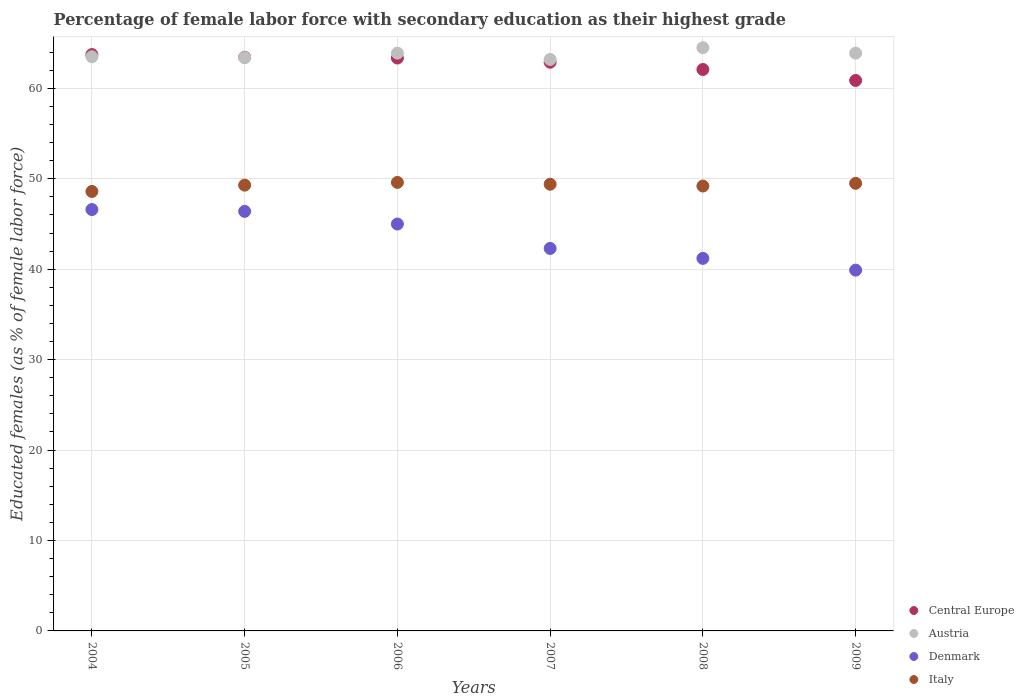What is the percentage of female labor force with secondary education in Austria in 2009?
Offer a very short reply. 63.9. Across all years, what is the maximum percentage of female labor force with secondary education in Central Europe?
Make the answer very short. 63.74. Across all years, what is the minimum percentage of female labor force with secondary education in Italy?
Give a very brief answer. 48.6. What is the total percentage of female labor force with secondary education in Italy in the graph?
Offer a very short reply. 295.6. What is the difference between the percentage of female labor force with secondary education in Italy in 2008 and that in 2009?
Your answer should be compact. -0.3. What is the difference between the percentage of female labor force with secondary education in Austria in 2004 and the percentage of female labor force with secondary education in Denmark in 2009?
Offer a very short reply. 23.6. What is the average percentage of female labor force with secondary education in Denmark per year?
Your response must be concise. 43.57. In the year 2004, what is the difference between the percentage of female labor force with secondary education in Austria and percentage of female labor force with secondary education in Central Europe?
Your answer should be compact. -0.24. What is the ratio of the percentage of female labor force with secondary education in Denmark in 2007 to that in 2009?
Ensure brevity in your answer.  1.06. Is the percentage of female labor force with secondary education in Italy in 2005 less than that in 2008?
Provide a succinct answer. No. What is the difference between the highest and the second highest percentage of female labor force with secondary education in Denmark?
Offer a very short reply. 0.2. What is the difference between the highest and the lowest percentage of female labor force with secondary education in Italy?
Make the answer very short. 1. Is the percentage of female labor force with secondary education in Italy strictly less than the percentage of female labor force with secondary education in Austria over the years?
Your answer should be compact. Yes. How many dotlines are there?
Ensure brevity in your answer.  4. What is the difference between two consecutive major ticks on the Y-axis?
Offer a terse response. 10. Does the graph contain any zero values?
Provide a short and direct response. No. Where does the legend appear in the graph?
Make the answer very short. Bottom right. How many legend labels are there?
Your answer should be compact. 4. What is the title of the graph?
Offer a very short reply. Percentage of female labor force with secondary education as their highest grade. What is the label or title of the Y-axis?
Ensure brevity in your answer.  Educated females (as % of female labor force). What is the Educated females (as % of female labor force) in Central Europe in 2004?
Ensure brevity in your answer.  63.74. What is the Educated females (as % of female labor force) in Austria in 2004?
Make the answer very short. 63.5. What is the Educated females (as % of female labor force) of Denmark in 2004?
Give a very brief answer. 46.6. What is the Educated females (as % of female labor force) of Italy in 2004?
Provide a succinct answer. 48.6. What is the Educated females (as % of female labor force) of Central Europe in 2005?
Your answer should be very brief. 63.44. What is the Educated females (as % of female labor force) in Austria in 2005?
Your answer should be very brief. 63.4. What is the Educated females (as % of female labor force) of Denmark in 2005?
Provide a short and direct response. 46.4. What is the Educated females (as % of female labor force) in Italy in 2005?
Offer a very short reply. 49.3. What is the Educated females (as % of female labor force) of Central Europe in 2006?
Provide a succinct answer. 63.36. What is the Educated females (as % of female labor force) of Austria in 2006?
Ensure brevity in your answer.  63.9. What is the Educated females (as % of female labor force) in Italy in 2006?
Offer a terse response. 49.6. What is the Educated females (as % of female labor force) in Central Europe in 2007?
Ensure brevity in your answer.  62.89. What is the Educated females (as % of female labor force) of Austria in 2007?
Offer a very short reply. 63.2. What is the Educated females (as % of female labor force) in Denmark in 2007?
Your answer should be compact. 42.3. What is the Educated females (as % of female labor force) of Italy in 2007?
Offer a terse response. 49.4. What is the Educated females (as % of female labor force) of Central Europe in 2008?
Ensure brevity in your answer.  62.09. What is the Educated females (as % of female labor force) in Austria in 2008?
Provide a succinct answer. 64.5. What is the Educated females (as % of female labor force) in Denmark in 2008?
Offer a very short reply. 41.2. What is the Educated females (as % of female labor force) in Italy in 2008?
Your answer should be very brief. 49.2. What is the Educated females (as % of female labor force) of Central Europe in 2009?
Offer a very short reply. 60.88. What is the Educated females (as % of female labor force) in Austria in 2009?
Your answer should be compact. 63.9. What is the Educated females (as % of female labor force) in Denmark in 2009?
Offer a very short reply. 39.9. What is the Educated females (as % of female labor force) in Italy in 2009?
Offer a terse response. 49.5. Across all years, what is the maximum Educated females (as % of female labor force) of Central Europe?
Your answer should be compact. 63.74. Across all years, what is the maximum Educated females (as % of female labor force) of Austria?
Provide a succinct answer. 64.5. Across all years, what is the maximum Educated females (as % of female labor force) in Denmark?
Offer a terse response. 46.6. Across all years, what is the maximum Educated females (as % of female labor force) in Italy?
Provide a succinct answer. 49.6. Across all years, what is the minimum Educated females (as % of female labor force) in Central Europe?
Your response must be concise. 60.88. Across all years, what is the minimum Educated females (as % of female labor force) in Austria?
Offer a terse response. 63.2. Across all years, what is the minimum Educated females (as % of female labor force) of Denmark?
Your answer should be compact. 39.9. Across all years, what is the minimum Educated females (as % of female labor force) of Italy?
Give a very brief answer. 48.6. What is the total Educated females (as % of female labor force) in Central Europe in the graph?
Your answer should be very brief. 376.39. What is the total Educated females (as % of female labor force) in Austria in the graph?
Make the answer very short. 382.4. What is the total Educated females (as % of female labor force) in Denmark in the graph?
Make the answer very short. 261.4. What is the total Educated females (as % of female labor force) in Italy in the graph?
Your response must be concise. 295.6. What is the difference between the Educated females (as % of female labor force) of Central Europe in 2004 and that in 2005?
Give a very brief answer. 0.3. What is the difference between the Educated females (as % of female labor force) of Austria in 2004 and that in 2005?
Provide a short and direct response. 0.1. What is the difference between the Educated females (as % of female labor force) of Central Europe in 2004 and that in 2006?
Your answer should be compact. 0.38. What is the difference between the Educated females (as % of female labor force) in Central Europe in 2004 and that in 2007?
Provide a succinct answer. 0.84. What is the difference between the Educated females (as % of female labor force) of Denmark in 2004 and that in 2007?
Keep it short and to the point. 4.3. What is the difference between the Educated females (as % of female labor force) of Central Europe in 2004 and that in 2008?
Offer a very short reply. 1.65. What is the difference between the Educated females (as % of female labor force) of Italy in 2004 and that in 2008?
Offer a terse response. -0.6. What is the difference between the Educated females (as % of female labor force) in Central Europe in 2004 and that in 2009?
Your answer should be very brief. 2.86. What is the difference between the Educated females (as % of female labor force) in Italy in 2004 and that in 2009?
Offer a very short reply. -0.9. What is the difference between the Educated females (as % of female labor force) of Central Europe in 2005 and that in 2006?
Your response must be concise. 0.08. What is the difference between the Educated females (as % of female labor force) of Denmark in 2005 and that in 2006?
Make the answer very short. 1.4. What is the difference between the Educated females (as % of female labor force) in Central Europe in 2005 and that in 2007?
Ensure brevity in your answer.  0.54. What is the difference between the Educated females (as % of female labor force) of Austria in 2005 and that in 2007?
Your response must be concise. 0.2. What is the difference between the Educated females (as % of female labor force) of Italy in 2005 and that in 2007?
Ensure brevity in your answer.  -0.1. What is the difference between the Educated females (as % of female labor force) in Central Europe in 2005 and that in 2008?
Provide a succinct answer. 1.34. What is the difference between the Educated females (as % of female labor force) in Austria in 2005 and that in 2008?
Offer a very short reply. -1.1. What is the difference between the Educated females (as % of female labor force) of Denmark in 2005 and that in 2008?
Keep it short and to the point. 5.2. What is the difference between the Educated females (as % of female labor force) of Italy in 2005 and that in 2008?
Provide a succinct answer. 0.1. What is the difference between the Educated females (as % of female labor force) of Central Europe in 2005 and that in 2009?
Provide a short and direct response. 2.56. What is the difference between the Educated females (as % of female labor force) in Austria in 2005 and that in 2009?
Your answer should be very brief. -0.5. What is the difference between the Educated females (as % of female labor force) in Italy in 2005 and that in 2009?
Offer a very short reply. -0.2. What is the difference between the Educated females (as % of female labor force) of Central Europe in 2006 and that in 2007?
Ensure brevity in your answer.  0.46. What is the difference between the Educated females (as % of female labor force) in Austria in 2006 and that in 2007?
Offer a terse response. 0.7. What is the difference between the Educated females (as % of female labor force) of Central Europe in 2006 and that in 2008?
Offer a very short reply. 1.27. What is the difference between the Educated females (as % of female labor force) of Austria in 2006 and that in 2008?
Keep it short and to the point. -0.6. What is the difference between the Educated females (as % of female labor force) of Italy in 2006 and that in 2008?
Ensure brevity in your answer.  0.4. What is the difference between the Educated females (as % of female labor force) in Central Europe in 2006 and that in 2009?
Offer a terse response. 2.48. What is the difference between the Educated females (as % of female labor force) of Denmark in 2006 and that in 2009?
Make the answer very short. 5.1. What is the difference between the Educated females (as % of female labor force) in Central Europe in 2007 and that in 2008?
Keep it short and to the point. 0.8. What is the difference between the Educated females (as % of female labor force) of Central Europe in 2007 and that in 2009?
Your answer should be compact. 2.01. What is the difference between the Educated females (as % of female labor force) of Austria in 2007 and that in 2009?
Your answer should be compact. -0.7. What is the difference between the Educated females (as % of female labor force) of Denmark in 2007 and that in 2009?
Give a very brief answer. 2.4. What is the difference between the Educated females (as % of female labor force) of Central Europe in 2008 and that in 2009?
Your answer should be compact. 1.21. What is the difference between the Educated females (as % of female labor force) of Austria in 2008 and that in 2009?
Ensure brevity in your answer.  0.6. What is the difference between the Educated females (as % of female labor force) in Italy in 2008 and that in 2009?
Keep it short and to the point. -0.3. What is the difference between the Educated females (as % of female labor force) in Central Europe in 2004 and the Educated females (as % of female labor force) in Austria in 2005?
Provide a short and direct response. 0.34. What is the difference between the Educated females (as % of female labor force) of Central Europe in 2004 and the Educated females (as % of female labor force) of Denmark in 2005?
Make the answer very short. 17.34. What is the difference between the Educated females (as % of female labor force) in Central Europe in 2004 and the Educated females (as % of female labor force) in Italy in 2005?
Keep it short and to the point. 14.44. What is the difference between the Educated females (as % of female labor force) in Austria in 2004 and the Educated females (as % of female labor force) in Denmark in 2005?
Your answer should be very brief. 17.1. What is the difference between the Educated females (as % of female labor force) of Austria in 2004 and the Educated females (as % of female labor force) of Italy in 2005?
Your answer should be compact. 14.2. What is the difference between the Educated females (as % of female labor force) in Denmark in 2004 and the Educated females (as % of female labor force) in Italy in 2005?
Provide a short and direct response. -2.7. What is the difference between the Educated females (as % of female labor force) in Central Europe in 2004 and the Educated females (as % of female labor force) in Austria in 2006?
Give a very brief answer. -0.16. What is the difference between the Educated females (as % of female labor force) of Central Europe in 2004 and the Educated females (as % of female labor force) of Denmark in 2006?
Provide a succinct answer. 18.74. What is the difference between the Educated females (as % of female labor force) in Central Europe in 2004 and the Educated females (as % of female labor force) in Italy in 2006?
Your response must be concise. 14.14. What is the difference between the Educated females (as % of female labor force) of Austria in 2004 and the Educated females (as % of female labor force) of Italy in 2006?
Ensure brevity in your answer.  13.9. What is the difference between the Educated females (as % of female labor force) in Central Europe in 2004 and the Educated females (as % of female labor force) in Austria in 2007?
Your answer should be very brief. 0.54. What is the difference between the Educated females (as % of female labor force) in Central Europe in 2004 and the Educated females (as % of female labor force) in Denmark in 2007?
Provide a succinct answer. 21.44. What is the difference between the Educated females (as % of female labor force) of Central Europe in 2004 and the Educated females (as % of female labor force) of Italy in 2007?
Provide a succinct answer. 14.34. What is the difference between the Educated females (as % of female labor force) of Austria in 2004 and the Educated females (as % of female labor force) of Denmark in 2007?
Provide a succinct answer. 21.2. What is the difference between the Educated females (as % of female labor force) in Austria in 2004 and the Educated females (as % of female labor force) in Italy in 2007?
Ensure brevity in your answer.  14.1. What is the difference between the Educated females (as % of female labor force) in Denmark in 2004 and the Educated females (as % of female labor force) in Italy in 2007?
Keep it short and to the point. -2.8. What is the difference between the Educated females (as % of female labor force) of Central Europe in 2004 and the Educated females (as % of female labor force) of Austria in 2008?
Make the answer very short. -0.76. What is the difference between the Educated females (as % of female labor force) in Central Europe in 2004 and the Educated females (as % of female labor force) in Denmark in 2008?
Make the answer very short. 22.54. What is the difference between the Educated females (as % of female labor force) of Central Europe in 2004 and the Educated females (as % of female labor force) of Italy in 2008?
Your response must be concise. 14.54. What is the difference between the Educated females (as % of female labor force) in Austria in 2004 and the Educated females (as % of female labor force) in Denmark in 2008?
Give a very brief answer. 22.3. What is the difference between the Educated females (as % of female labor force) of Austria in 2004 and the Educated females (as % of female labor force) of Italy in 2008?
Provide a succinct answer. 14.3. What is the difference between the Educated females (as % of female labor force) in Denmark in 2004 and the Educated females (as % of female labor force) in Italy in 2008?
Your answer should be very brief. -2.6. What is the difference between the Educated females (as % of female labor force) of Central Europe in 2004 and the Educated females (as % of female labor force) of Austria in 2009?
Your answer should be very brief. -0.16. What is the difference between the Educated females (as % of female labor force) in Central Europe in 2004 and the Educated females (as % of female labor force) in Denmark in 2009?
Give a very brief answer. 23.84. What is the difference between the Educated females (as % of female labor force) of Central Europe in 2004 and the Educated females (as % of female labor force) of Italy in 2009?
Keep it short and to the point. 14.24. What is the difference between the Educated females (as % of female labor force) in Austria in 2004 and the Educated females (as % of female labor force) in Denmark in 2009?
Your response must be concise. 23.6. What is the difference between the Educated females (as % of female labor force) in Austria in 2004 and the Educated females (as % of female labor force) in Italy in 2009?
Make the answer very short. 14. What is the difference between the Educated females (as % of female labor force) of Denmark in 2004 and the Educated females (as % of female labor force) of Italy in 2009?
Provide a short and direct response. -2.9. What is the difference between the Educated females (as % of female labor force) of Central Europe in 2005 and the Educated females (as % of female labor force) of Austria in 2006?
Your answer should be very brief. -0.46. What is the difference between the Educated females (as % of female labor force) in Central Europe in 2005 and the Educated females (as % of female labor force) in Denmark in 2006?
Keep it short and to the point. 18.44. What is the difference between the Educated females (as % of female labor force) of Central Europe in 2005 and the Educated females (as % of female labor force) of Italy in 2006?
Your answer should be very brief. 13.84. What is the difference between the Educated females (as % of female labor force) of Austria in 2005 and the Educated females (as % of female labor force) of Italy in 2006?
Provide a short and direct response. 13.8. What is the difference between the Educated females (as % of female labor force) of Denmark in 2005 and the Educated females (as % of female labor force) of Italy in 2006?
Your response must be concise. -3.2. What is the difference between the Educated females (as % of female labor force) in Central Europe in 2005 and the Educated females (as % of female labor force) in Austria in 2007?
Make the answer very short. 0.24. What is the difference between the Educated females (as % of female labor force) in Central Europe in 2005 and the Educated females (as % of female labor force) in Denmark in 2007?
Give a very brief answer. 21.14. What is the difference between the Educated females (as % of female labor force) in Central Europe in 2005 and the Educated females (as % of female labor force) in Italy in 2007?
Keep it short and to the point. 14.04. What is the difference between the Educated females (as % of female labor force) of Austria in 2005 and the Educated females (as % of female labor force) of Denmark in 2007?
Give a very brief answer. 21.1. What is the difference between the Educated females (as % of female labor force) in Austria in 2005 and the Educated females (as % of female labor force) in Italy in 2007?
Your answer should be very brief. 14. What is the difference between the Educated females (as % of female labor force) of Denmark in 2005 and the Educated females (as % of female labor force) of Italy in 2007?
Your answer should be very brief. -3. What is the difference between the Educated females (as % of female labor force) of Central Europe in 2005 and the Educated females (as % of female labor force) of Austria in 2008?
Keep it short and to the point. -1.06. What is the difference between the Educated females (as % of female labor force) of Central Europe in 2005 and the Educated females (as % of female labor force) of Denmark in 2008?
Provide a short and direct response. 22.24. What is the difference between the Educated females (as % of female labor force) in Central Europe in 2005 and the Educated females (as % of female labor force) in Italy in 2008?
Your answer should be very brief. 14.24. What is the difference between the Educated females (as % of female labor force) in Austria in 2005 and the Educated females (as % of female labor force) in Denmark in 2008?
Make the answer very short. 22.2. What is the difference between the Educated females (as % of female labor force) in Denmark in 2005 and the Educated females (as % of female labor force) in Italy in 2008?
Your response must be concise. -2.8. What is the difference between the Educated females (as % of female labor force) of Central Europe in 2005 and the Educated females (as % of female labor force) of Austria in 2009?
Give a very brief answer. -0.46. What is the difference between the Educated females (as % of female labor force) of Central Europe in 2005 and the Educated females (as % of female labor force) of Denmark in 2009?
Give a very brief answer. 23.54. What is the difference between the Educated females (as % of female labor force) of Central Europe in 2005 and the Educated females (as % of female labor force) of Italy in 2009?
Keep it short and to the point. 13.94. What is the difference between the Educated females (as % of female labor force) in Austria in 2005 and the Educated females (as % of female labor force) in Denmark in 2009?
Keep it short and to the point. 23.5. What is the difference between the Educated females (as % of female labor force) of Austria in 2005 and the Educated females (as % of female labor force) of Italy in 2009?
Provide a succinct answer. 13.9. What is the difference between the Educated females (as % of female labor force) in Central Europe in 2006 and the Educated females (as % of female labor force) in Austria in 2007?
Your response must be concise. 0.16. What is the difference between the Educated females (as % of female labor force) in Central Europe in 2006 and the Educated females (as % of female labor force) in Denmark in 2007?
Provide a succinct answer. 21.06. What is the difference between the Educated females (as % of female labor force) of Central Europe in 2006 and the Educated females (as % of female labor force) of Italy in 2007?
Provide a short and direct response. 13.96. What is the difference between the Educated females (as % of female labor force) of Austria in 2006 and the Educated females (as % of female labor force) of Denmark in 2007?
Provide a short and direct response. 21.6. What is the difference between the Educated females (as % of female labor force) of Denmark in 2006 and the Educated females (as % of female labor force) of Italy in 2007?
Your answer should be compact. -4.4. What is the difference between the Educated females (as % of female labor force) of Central Europe in 2006 and the Educated females (as % of female labor force) of Austria in 2008?
Make the answer very short. -1.14. What is the difference between the Educated females (as % of female labor force) of Central Europe in 2006 and the Educated females (as % of female labor force) of Denmark in 2008?
Keep it short and to the point. 22.16. What is the difference between the Educated females (as % of female labor force) of Central Europe in 2006 and the Educated females (as % of female labor force) of Italy in 2008?
Your answer should be compact. 14.16. What is the difference between the Educated females (as % of female labor force) in Austria in 2006 and the Educated females (as % of female labor force) in Denmark in 2008?
Your answer should be compact. 22.7. What is the difference between the Educated females (as % of female labor force) of Austria in 2006 and the Educated females (as % of female labor force) of Italy in 2008?
Your answer should be compact. 14.7. What is the difference between the Educated females (as % of female labor force) of Denmark in 2006 and the Educated females (as % of female labor force) of Italy in 2008?
Provide a succinct answer. -4.2. What is the difference between the Educated females (as % of female labor force) of Central Europe in 2006 and the Educated females (as % of female labor force) of Austria in 2009?
Give a very brief answer. -0.54. What is the difference between the Educated females (as % of female labor force) of Central Europe in 2006 and the Educated females (as % of female labor force) of Denmark in 2009?
Your response must be concise. 23.46. What is the difference between the Educated females (as % of female labor force) of Central Europe in 2006 and the Educated females (as % of female labor force) of Italy in 2009?
Your answer should be compact. 13.86. What is the difference between the Educated females (as % of female labor force) of Austria in 2006 and the Educated females (as % of female labor force) of Denmark in 2009?
Your answer should be compact. 24. What is the difference between the Educated females (as % of female labor force) of Austria in 2006 and the Educated females (as % of female labor force) of Italy in 2009?
Offer a terse response. 14.4. What is the difference between the Educated females (as % of female labor force) of Denmark in 2006 and the Educated females (as % of female labor force) of Italy in 2009?
Ensure brevity in your answer.  -4.5. What is the difference between the Educated females (as % of female labor force) of Central Europe in 2007 and the Educated females (as % of female labor force) of Austria in 2008?
Offer a terse response. -1.61. What is the difference between the Educated females (as % of female labor force) in Central Europe in 2007 and the Educated females (as % of female labor force) in Denmark in 2008?
Offer a very short reply. 21.69. What is the difference between the Educated females (as % of female labor force) in Central Europe in 2007 and the Educated females (as % of female labor force) in Italy in 2008?
Your answer should be compact. 13.69. What is the difference between the Educated females (as % of female labor force) in Austria in 2007 and the Educated females (as % of female labor force) in Denmark in 2008?
Offer a terse response. 22. What is the difference between the Educated females (as % of female labor force) of Central Europe in 2007 and the Educated females (as % of female labor force) of Austria in 2009?
Keep it short and to the point. -1.01. What is the difference between the Educated females (as % of female labor force) in Central Europe in 2007 and the Educated females (as % of female labor force) in Denmark in 2009?
Your answer should be compact. 22.99. What is the difference between the Educated females (as % of female labor force) of Central Europe in 2007 and the Educated females (as % of female labor force) of Italy in 2009?
Keep it short and to the point. 13.39. What is the difference between the Educated females (as % of female labor force) of Austria in 2007 and the Educated females (as % of female labor force) of Denmark in 2009?
Offer a very short reply. 23.3. What is the difference between the Educated females (as % of female labor force) in Austria in 2007 and the Educated females (as % of female labor force) in Italy in 2009?
Offer a terse response. 13.7. What is the difference between the Educated females (as % of female labor force) in Central Europe in 2008 and the Educated females (as % of female labor force) in Austria in 2009?
Your answer should be very brief. -1.81. What is the difference between the Educated females (as % of female labor force) in Central Europe in 2008 and the Educated females (as % of female labor force) in Denmark in 2009?
Ensure brevity in your answer.  22.19. What is the difference between the Educated females (as % of female labor force) of Central Europe in 2008 and the Educated females (as % of female labor force) of Italy in 2009?
Your answer should be very brief. 12.59. What is the difference between the Educated females (as % of female labor force) in Austria in 2008 and the Educated females (as % of female labor force) in Denmark in 2009?
Your response must be concise. 24.6. What is the difference between the Educated females (as % of female labor force) of Austria in 2008 and the Educated females (as % of female labor force) of Italy in 2009?
Your answer should be very brief. 15. What is the average Educated females (as % of female labor force) in Central Europe per year?
Give a very brief answer. 62.73. What is the average Educated females (as % of female labor force) of Austria per year?
Provide a succinct answer. 63.73. What is the average Educated females (as % of female labor force) of Denmark per year?
Your answer should be very brief. 43.57. What is the average Educated females (as % of female labor force) in Italy per year?
Provide a short and direct response. 49.27. In the year 2004, what is the difference between the Educated females (as % of female labor force) in Central Europe and Educated females (as % of female labor force) in Austria?
Your response must be concise. 0.24. In the year 2004, what is the difference between the Educated females (as % of female labor force) of Central Europe and Educated females (as % of female labor force) of Denmark?
Offer a terse response. 17.14. In the year 2004, what is the difference between the Educated females (as % of female labor force) of Central Europe and Educated females (as % of female labor force) of Italy?
Provide a short and direct response. 15.14. In the year 2004, what is the difference between the Educated females (as % of female labor force) in Austria and Educated females (as % of female labor force) in Denmark?
Your response must be concise. 16.9. In the year 2005, what is the difference between the Educated females (as % of female labor force) in Central Europe and Educated females (as % of female labor force) in Austria?
Your response must be concise. 0.04. In the year 2005, what is the difference between the Educated females (as % of female labor force) in Central Europe and Educated females (as % of female labor force) in Denmark?
Make the answer very short. 17.04. In the year 2005, what is the difference between the Educated females (as % of female labor force) in Central Europe and Educated females (as % of female labor force) in Italy?
Your response must be concise. 14.14. In the year 2005, what is the difference between the Educated females (as % of female labor force) of Austria and Educated females (as % of female labor force) of Denmark?
Offer a terse response. 17. In the year 2006, what is the difference between the Educated females (as % of female labor force) of Central Europe and Educated females (as % of female labor force) of Austria?
Provide a short and direct response. -0.54. In the year 2006, what is the difference between the Educated females (as % of female labor force) in Central Europe and Educated females (as % of female labor force) in Denmark?
Keep it short and to the point. 18.36. In the year 2006, what is the difference between the Educated females (as % of female labor force) in Central Europe and Educated females (as % of female labor force) in Italy?
Your answer should be compact. 13.76. In the year 2006, what is the difference between the Educated females (as % of female labor force) of Austria and Educated females (as % of female labor force) of Italy?
Ensure brevity in your answer.  14.3. In the year 2007, what is the difference between the Educated females (as % of female labor force) in Central Europe and Educated females (as % of female labor force) in Austria?
Ensure brevity in your answer.  -0.31. In the year 2007, what is the difference between the Educated females (as % of female labor force) of Central Europe and Educated females (as % of female labor force) of Denmark?
Provide a succinct answer. 20.59. In the year 2007, what is the difference between the Educated females (as % of female labor force) in Central Europe and Educated females (as % of female labor force) in Italy?
Your answer should be compact. 13.49. In the year 2007, what is the difference between the Educated females (as % of female labor force) of Austria and Educated females (as % of female labor force) of Denmark?
Ensure brevity in your answer.  20.9. In the year 2007, what is the difference between the Educated females (as % of female labor force) of Denmark and Educated females (as % of female labor force) of Italy?
Provide a succinct answer. -7.1. In the year 2008, what is the difference between the Educated females (as % of female labor force) of Central Europe and Educated females (as % of female labor force) of Austria?
Ensure brevity in your answer.  -2.41. In the year 2008, what is the difference between the Educated females (as % of female labor force) of Central Europe and Educated females (as % of female labor force) of Denmark?
Offer a very short reply. 20.89. In the year 2008, what is the difference between the Educated females (as % of female labor force) of Central Europe and Educated females (as % of female labor force) of Italy?
Provide a short and direct response. 12.89. In the year 2008, what is the difference between the Educated females (as % of female labor force) of Austria and Educated females (as % of female labor force) of Denmark?
Offer a very short reply. 23.3. In the year 2008, what is the difference between the Educated females (as % of female labor force) in Austria and Educated females (as % of female labor force) in Italy?
Your answer should be very brief. 15.3. In the year 2009, what is the difference between the Educated females (as % of female labor force) in Central Europe and Educated females (as % of female labor force) in Austria?
Provide a short and direct response. -3.02. In the year 2009, what is the difference between the Educated females (as % of female labor force) of Central Europe and Educated females (as % of female labor force) of Denmark?
Give a very brief answer. 20.98. In the year 2009, what is the difference between the Educated females (as % of female labor force) in Central Europe and Educated females (as % of female labor force) in Italy?
Your answer should be very brief. 11.38. In the year 2009, what is the difference between the Educated females (as % of female labor force) in Austria and Educated females (as % of female labor force) in Italy?
Give a very brief answer. 14.4. In the year 2009, what is the difference between the Educated females (as % of female labor force) in Denmark and Educated females (as % of female labor force) in Italy?
Your answer should be compact. -9.6. What is the ratio of the Educated females (as % of female labor force) in Austria in 2004 to that in 2005?
Ensure brevity in your answer.  1. What is the ratio of the Educated females (as % of female labor force) in Italy in 2004 to that in 2005?
Your answer should be compact. 0.99. What is the ratio of the Educated females (as % of female labor force) in Central Europe in 2004 to that in 2006?
Offer a very short reply. 1.01. What is the ratio of the Educated females (as % of female labor force) of Denmark in 2004 to that in 2006?
Ensure brevity in your answer.  1.04. What is the ratio of the Educated females (as % of female labor force) of Italy in 2004 to that in 2006?
Your answer should be very brief. 0.98. What is the ratio of the Educated females (as % of female labor force) in Central Europe in 2004 to that in 2007?
Ensure brevity in your answer.  1.01. What is the ratio of the Educated females (as % of female labor force) in Austria in 2004 to that in 2007?
Your answer should be compact. 1. What is the ratio of the Educated females (as % of female labor force) of Denmark in 2004 to that in 2007?
Make the answer very short. 1.1. What is the ratio of the Educated females (as % of female labor force) of Italy in 2004 to that in 2007?
Keep it short and to the point. 0.98. What is the ratio of the Educated females (as % of female labor force) in Central Europe in 2004 to that in 2008?
Offer a very short reply. 1.03. What is the ratio of the Educated females (as % of female labor force) in Austria in 2004 to that in 2008?
Your response must be concise. 0.98. What is the ratio of the Educated females (as % of female labor force) in Denmark in 2004 to that in 2008?
Ensure brevity in your answer.  1.13. What is the ratio of the Educated females (as % of female labor force) in Italy in 2004 to that in 2008?
Offer a terse response. 0.99. What is the ratio of the Educated females (as % of female labor force) in Central Europe in 2004 to that in 2009?
Give a very brief answer. 1.05. What is the ratio of the Educated females (as % of female labor force) in Austria in 2004 to that in 2009?
Provide a short and direct response. 0.99. What is the ratio of the Educated females (as % of female labor force) in Denmark in 2004 to that in 2009?
Provide a succinct answer. 1.17. What is the ratio of the Educated females (as % of female labor force) in Italy in 2004 to that in 2009?
Make the answer very short. 0.98. What is the ratio of the Educated females (as % of female labor force) of Central Europe in 2005 to that in 2006?
Make the answer very short. 1. What is the ratio of the Educated females (as % of female labor force) of Denmark in 2005 to that in 2006?
Give a very brief answer. 1.03. What is the ratio of the Educated females (as % of female labor force) in Central Europe in 2005 to that in 2007?
Your response must be concise. 1.01. What is the ratio of the Educated females (as % of female labor force) in Denmark in 2005 to that in 2007?
Offer a terse response. 1.1. What is the ratio of the Educated females (as % of female labor force) of Central Europe in 2005 to that in 2008?
Your response must be concise. 1.02. What is the ratio of the Educated females (as % of female labor force) in Austria in 2005 to that in 2008?
Ensure brevity in your answer.  0.98. What is the ratio of the Educated females (as % of female labor force) in Denmark in 2005 to that in 2008?
Make the answer very short. 1.13. What is the ratio of the Educated females (as % of female labor force) in Italy in 2005 to that in 2008?
Keep it short and to the point. 1. What is the ratio of the Educated females (as % of female labor force) of Central Europe in 2005 to that in 2009?
Give a very brief answer. 1.04. What is the ratio of the Educated females (as % of female labor force) of Denmark in 2005 to that in 2009?
Your response must be concise. 1.16. What is the ratio of the Educated females (as % of female labor force) in Central Europe in 2006 to that in 2007?
Your answer should be compact. 1.01. What is the ratio of the Educated females (as % of female labor force) of Austria in 2006 to that in 2007?
Offer a very short reply. 1.01. What is the ratio of the Educated females (as % of female labor force) of Denmark in 2006 to that in 2007?
Your response must be concise. 1.06. What is the ratio of the Educated females (as % of female labor force) of Central Europe in 2006 to that in 2008?
Offer a very short reply. 1.02. What is the ratio of the Educated females (as % of female labor force) in Denmark in 2006 to that in 2008?
Provide a succinct answer. 1.09. What is the ratio of the Educated females (as % of female labor force) of Central Europe in 2006 to that in 2009?
Provide a short and direct response. 1.04. What is the ratio of the Educated females (as % of female labor force) of Austria in 2006 to that in 2009?
Ensure brevity in your answer.  1. What is the ratio of the Educated females (as % of female labor force) in Denmark in 2006 to that in 2009?
Give a very brief answer. 1.13. What is the ratio of the Educated females (as % of female labor force) of Central Europe in 2007 to that in 2008?
Your answer should be compact. 1.01. What is the ratio of the Educated females (as % of female labor force) of Austria in 2007 to that in 2008?
Make the answer very short. 0.98. What is the ratio of the Educated females (as % of female labor force) in Denmark in 2007 to that in 2008?
Offer a very short reply. 1.03. What is the ratio of the Educated females (as % of female labor force) in Central Europe in 2007 to that in 2009?
Keep it short and to the point. 1.03. What is the ratio of the Educated females (as % of female labor force) in Denmark in 2007 to that in 2009?
Offer a very short reply. 1.06. What is the ratio of the Educated females (as % of female labor force) in Italy in 2007 to that in 2009?
Give a very brief answer. 1. What is the ratio of the Educated females (as % of female labor force) of Central Europe in 2008 to that in 2009?
Provide a short and direct response. 1.02. What is the ratio of the Educated females (as % of female labor force) in Austria in 2008 to that in 2009?
Offer a very short reply. 1.01. What is the ratio of the Educated females (as % of female labor force) of Denmark in 2008 to that in 2009?
Your answer should be very brief. 1.03. What is the difference between the highest and the second highest Educated females (as % of female labor force) in Central Europe?
Ensure brevity in your answer.  0.3. What is the difference between the highest and the second highest Educated females (as % of female labor force) of Denmark?
Offer a terse response. 0.2. What is the difference between the highest and the lowest Educated females (as % of female labor force) in Central Europe?
Offer a very short reply. 2.86. What is the difference between the highest and the lowest Educated females (as % of female labor force) in Austria?
Ensure brevity in your answer.  1.3. What is the difference between the highest and the lowest Educated females (as % of female labor force) in Italy?
Your response must be concise. 1. 